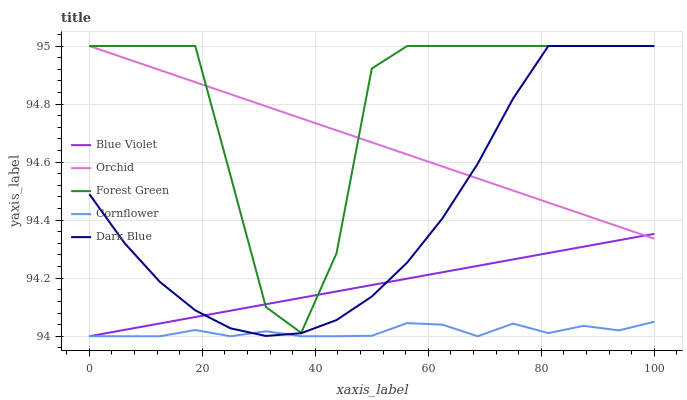Does Cornflower have the minimum area under the curve?
Answer yes or no. Yes. Does Forest Green have the maximum area under the curve?
Answer yes or no. Yes. Does Dark Blue have the minimum area under the curve?
Answer yes or no. No. Does Dark Blue have the maximum area under the curve?
Answer yes or no. No. Is Orchid the smoothest?
Answer yes or no. Yes. Is Forest Green the roughest?
Answer yes or no. Yes. Is Dark Blue the smoothest?
Answer yes or no. No. Is Dark Blue the roughest?
Answer yes or no. No. Does Forest Green have the lowest value?
Answer yes or no. No. Does Orchid have the highest value?
Answer yes or no. Yes. Does Blue Violet have the highest value?
Answer yes or no. No. Is Cornflower less than Forest Green?
Answer yes or no. Yes. Is Forest Green greater than Cornflower?
Answer yes or no. Yes. Does Forest Green intersect Dark Blue?
Answer yes or no. Yes. Is Forest Green less than Dark Blue?
Answer yes or no. No. Is Forest Green greater than Dark Blue?
Answer yes or no. No. Does Cornflower intersect Forest Green?
Answer yes or no. No. 